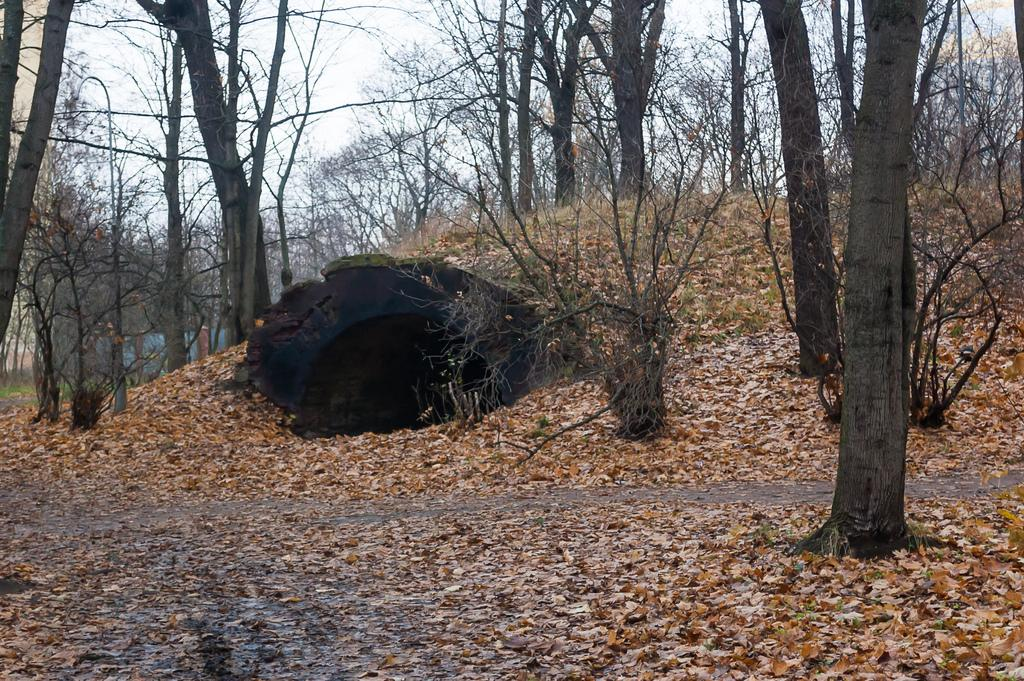What is the main subject in the middle of the image? There is a cave in the middle of the image. What type of vegetation can be seen in the image? There are trees in the image. What is visible at the top of the image? The sky is visible at the top of the image. What is present at the bottom of the image? Dried leaves are present at the bottom of the image. What type of hair can be seen on the trees in the image? There is no hair present on the trees in the image; they are covered with leaves. 